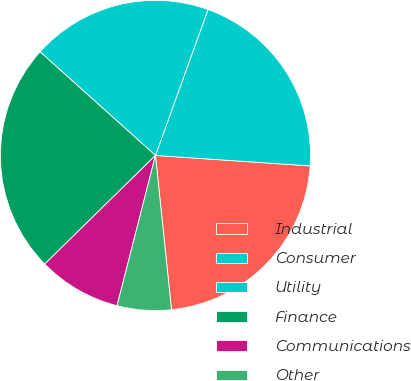<chart> <loc_0><loc_0><loc_500><loc_500><pie_chart><fcel>Industrial<fcel>Consumer<fcel>Utility<fcel>Finance<fcel>Communications<fcel>Other<nl><fcel>22.28%<fcel>20.57%<fcel>18.86%<fcel>23.99%<fcel>8.67%<fcel>5.63%<nl></chart> 